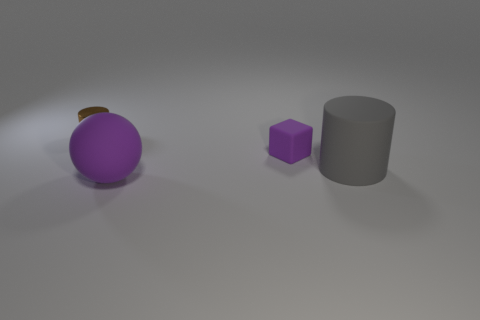There is a matte thing on the left side of the small purple cube; does it have the same color as the matte thing behind the gray rubber thing?
Your answer should be compact. Yes. There is a rubber object that is the same color as the large ball; what size is it?
Your answer should be compact. Small. How many other objects are the same size as the block?
Provide a short and direct response. 1. The cylinder that is in front of the tiny brown cylinder is what color?
Provide a succinct answer. Gray. Is the material of the big thing in front of the big gray object the same as the tiny brown cylinder?
Offer a terse response. No. How many cylinders are to the left of the big purple matte sphere and in front of the brown thing?
Make the answer very short. 0. The object to the right of the tiny purple block behind the large matte object that is to the left of the gray thing is what color?
Ensure brevity in your answer.  Gray. How many other things are the same shape as the tiny purple object?
Make the answer very short. 0. There is a thing left of the big purple ball; is there a gray rubber cylinder that is on the right side of it?
Offer a very short reply. Yes. What number of shiny objects are either big purple things or small blue cylinders?
Make the answer very short. 0. 